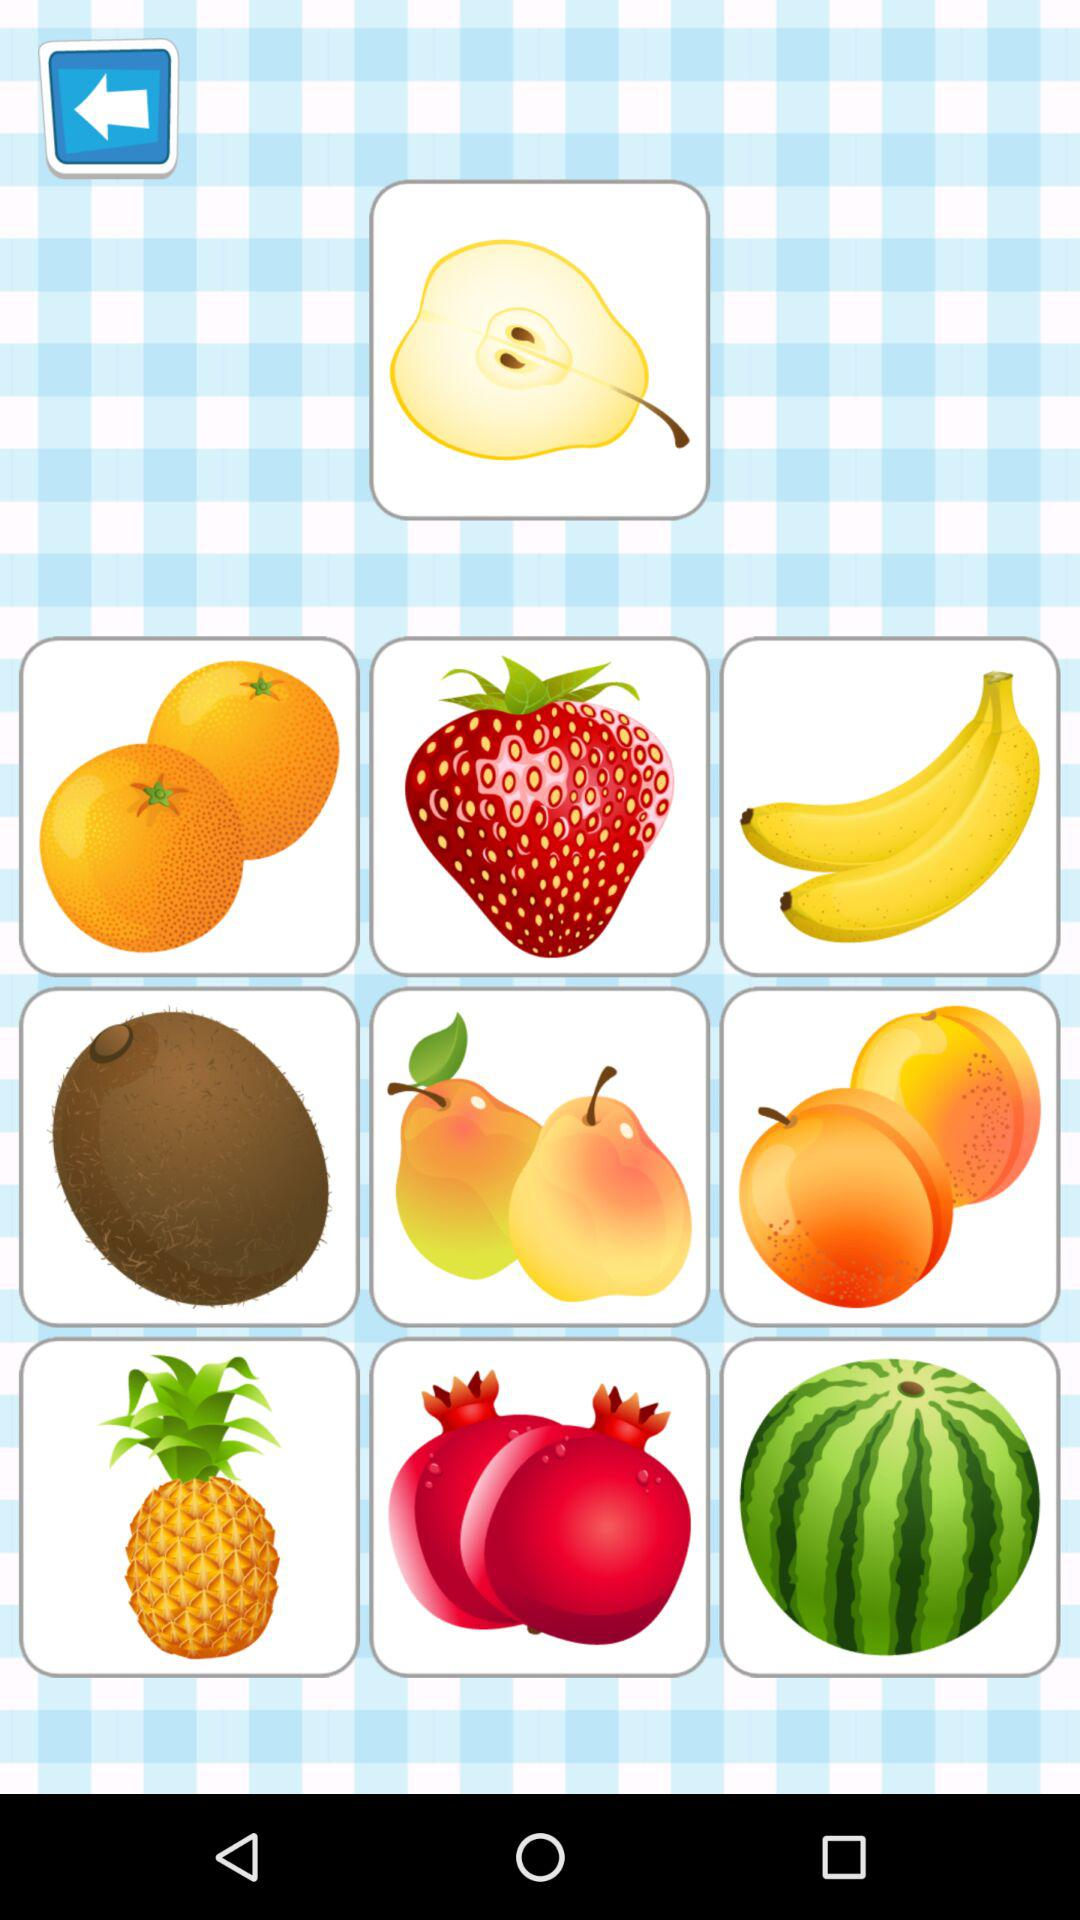How many items have a leaf on them?
Answer the question using a single word or phrase. 3 